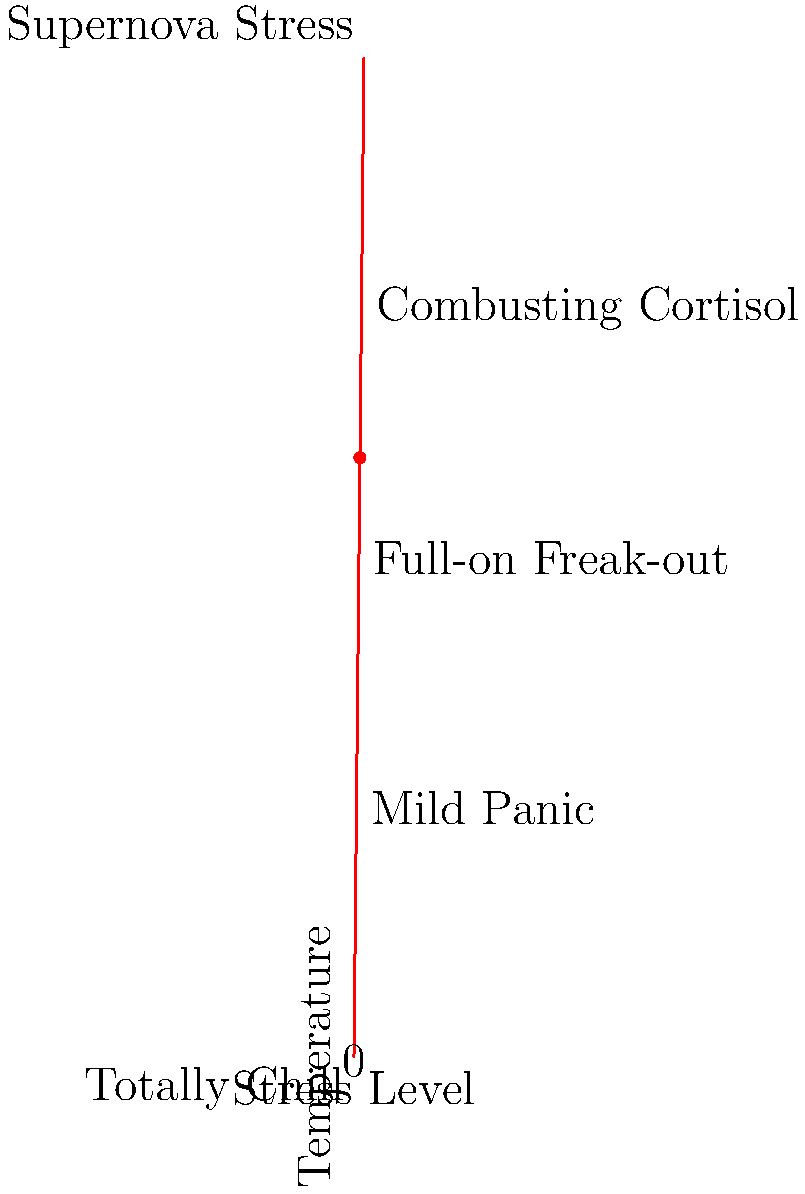As a clinical psychologist who likes to inject humor into sessions, you've created a "Stress-o-meter" to help patients visualize their stress levels. Based on the thermometer-style graphic, at what humorous stress level would you place a patient whose stress indicator falls at the red dot? To determine the patient's stress level based on the humorous "Stress-o-meter":

1. Observe the position of the red dot on the thermometer scale.
2. The dot is located at approximately 60% of the total height.
3. Looking at the labeled stress levels:
   - "Totally Chill" is at 0%
   - "Mild Panic" is around 25%
   - "Full-on Freak-out" is at 50%
   - "Combusting Cortisol" is at 75%
   - "Supernova Stress" is at 100%
4. The red dot falls between "Full-on Freak-out" (50%) and "Combusting Cortisol" (75%).
5. Since it's closer to "Combusting Cortisol," this would be the most appropriate humorous stress indicator for the patient's current level.
Answer: Combusting Cortisol 